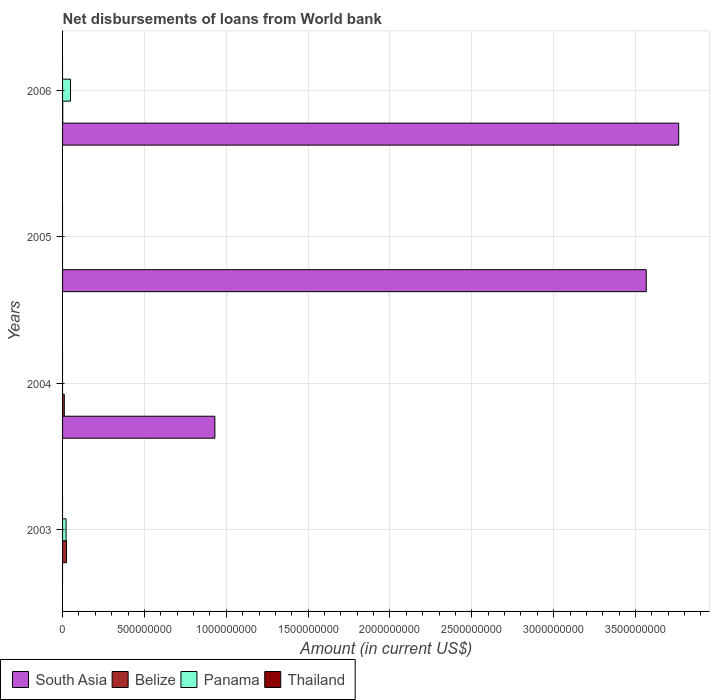How many different coloured bars are there?
Your answer should be very brief. 3. Are the number of bars per tick equal to the number of legend labels?
Offer a very short reply. No. How many bars are there on the 4th tick from the bottom?
Your response must be concise. 3. What is the label of the 4th group of bars from the top?
Ensure brevity in your answer.  2003. In how many cases, is the number of bars for a given year not equal to the number of legend labels?
Offer a terse response. 4. What is the amount of loan disbursed from World Bank in Thailand in 2006?
Make the answer very short. 0. Across all years, what is the maximum amount of loan disbursed from World Bank in Belize?
Make the answer very short. 2.42e+07. What is the total amount of loan disbursed from World Bank in Belize in the graph?
Offer a terse response. 3.57e+07. What is the difference between the amount of loan disbursed from World Bank in Belize in 2003 and that in 2004?
Provide a short and direct response. 1.36e+07. What is the average amount of loan disbursed from World Bank in Panama per year?
Offer a very short reply. 1.75e+07. In the year 2006, what is the difference between the amount of loan disbursed from World Bank in Belize and amount of loan disbursed from World Bank in South Asia?
Your response must be concise. -3.76e+09. In how many years, is the amount of loan disbursed from World Bank in Belize greater than 600000000 US$?
Your answer should be very brief. 0. What is the ratio of the amount of loan disbursed from World Bank in Belize in 2003 to that in 2006?
Keep it short and to the point. 26.44. Is the amount of loan disbursed from World Bank in South Asia in 2004 less than that in 2005?
Give a very brief answer. Yes. What is the difference between the highest and the second highest amount of loan disbursed from World Bank in South Asia?
Your answer should be very brief. 1.98e+08. What is the difference between the highest and the lowest amount of loan disbursed from World Bank in Panama?
Offer a terse response. 4.86e+07. In how many years, is the amount of loan disbursed from World Bank in South Asia greater than the average amount of loan disbursed from World Bank in South Asia taken over all years?
Offer a terse response. 2. Is the sum of the amount of loan disbursed from World Bank in South Asia in 2005 and 2006 greater than the maximum amount of loan disbursed from World Bank in Panama across all years?
Provide a succinct answer. Yes. Is it the case that in every year, the sum of the amount of loan disbursed from World Bank in South Asia and amount of loan disbursed from World Bank in Belize is greater than the amount of loan disbursed from World Bank in Panama?
Your response must be concise. Yes. How many bars are there?
Your response must be concise. 8. How many years are there in the graph?
Keep it short and to the point. 4. Does the graph contain grids?
Provide a succinct answer. Yes. How many legend labels are there?
Ensure brevity in your answer.  4. How are the legend labels stacked?
Your answer should be very brief. Horizontal. What is the title of the graph?
Give a very brief answer. Net disbursements of loans from World bank. What is the label or title of the Y-axis?
Give a very brief answer. Years. What is the Amount (in current US$) in South Asia in 2003?
Your answer should be compact. 0. What is the Amount (in current US$) in Belize in 2003?
Keep it short and to the point. 2.42e+07. What is the Amount (in current US$) of Panama in 2003?
Your response must be concise. 2.14e+07. What is the Amount (in current US$) in Thailand in 2003?
Your response must be concise. 0. What is the Amount (in current US$) of South Asia in 2004?
Offer a terse response. 9.30e+08. What is the Amount (in current US$) in Belize in 2004?
Ensure brevity in your answer.  1.06e+07. What is the Amount (in current US$) in Thailand in 2004?
Ensure brevity in your answer.  0. What is the Amount (in current US$) in South Asia in 2005?
Offer a very short reply. 3.57e+09. What is the Amount (in current US$) in Panama in 2005?
Provide a short and direct response. 0. What is the Amount (in current US$) in South Asia in 2006?
Ensure brevity in your answer.  3.76e+09. What is the Amount (in current US$) of Belize in 2006?
Your response must be concise. 9.15e+05. What is the Amount (in current US$) in Panama in 2006?
Ensure brevity in your answer.  4.86e+07. Across all years, what is the maximum Amount (in current US$) in South Asia?
Your answer should be very brief. 3.76e+09. Across all years, what is the maximum Amount (in current US$) in Belize?
Make the answer very short. 2.42e+07. Across all years, what is the maximum Amount (in current US$) of Panama?
Your response must be concise. 4.86e+07. Across all years, what is the minimum Amount (in current US$) of South Asia?
Offer a terse response. 0. Across all years, what is the minimum Amount (in current US$) in Belize?
Your answer should be compact. 0. Across all years, what is the minimum Amount (in current US$) of Panama?
Your response must be concise. 0. What is the total Amount (in current US$) of South Asia in the graph?
Your response must be concise. 8.26e+09. What is the total Amount (in current US$) in Belize in the graph?
Ensure brevity in your answer.  3.57e+07. What is the total Amount (in current US$) of Panama in the graph?
Make the answer very short. 7.00e+07. What is the total Amount (in current US$) of Thailand in the graph?
Your answer should be compact. 0. What is the difference between the Amount (in current US$) in Belize in 2003 and that in 2004?
Your answer should be very brief. 1.36e+07. What is the difference between the Amount (in current US$) of Belize in 2003 and that in 2006?
Make the answer very short. 2.33e+07. What is the difference between the Amount (in current US$) of Panama in 2003 and that in 2006?
Your response must be concise. -2.72e+07. What is the difference between the Amount (in current US$) of South Asia in 2004 and that in 2005?
Provide a succinct answer. -2.64e+09. What is the difference between the Amount (in current US$) of South Asia in 2004 and that in 2006?
Provide a succinct answer. -2.83e+09. What is the difference between the Amount (in current US$) in Belize in 2004 and that in 2006?
Provide a short and direct response. 9.71e+06. What is the difference between the Amount (in current US$) in South Asia in 2005 and that in 2006?
Offer a terse response. -1.98e+08. What is the difference between the Amount (in current US$) of Belize in 2003 and the Amount (in current US$) of Panama in 2006?
Your answer should be very brief. -2.44e+07. What is the difference between the Amount (in current US$) of South Asia in 2004 and the Amount (in current US$) of Belize in 2006?
Keep it short and to the point. 9.29e+08. What is the difference between the Amount (in current US$) in South Asia in 2004 and the Amount (in current US$) in Panama in 2006?
Your answer should be very brief. 8.82e+08. What is the difference between the Amount (in current US$) in Belize in 2004 and the Amount (in current US$) in Panama in 2006?
Ensure brevity in your answer.  -3.80e+07. What is the difference between the Amount (in current US$) in South Asia in 2005 and the Amount (in current US$) in Belize in 2006?
Your response must be concise. 3.56e+09. What is the difference between the Amount (in current US$) of South Asia in 2005 and the Amount (in current US$) of Panama in 2006?
Keep it short and to the point. 3.52e+09. What is the average Amount (in current US$) in South Asia per year?
Your answer should be very brief. 2.06e+09. What is the average Amount (in current US$) of Belize per year?
Your answer should be very brief. 8.93e+06. What is the average Amount (in current US$) of Panama per year?
Your response must be concise. 1.75e+07. What is the average Amount (in current US$) of Thailand per year?
Offer a terse response. 0. In the year 2003, what is the difference between the Amount (in current US$) of Belize and Amount (in current US$) of Panama?
Your answer should be compact. 2.79e+06. In the year 2004, what is the difference between the Amount (in current US$) of South Asia and Amount (in current US$) of Belize?
Provide a succinct answer. 9.20e+08. In the year 2006, what is the difference between the Amount (in current US$) in South Asia and Amount (in current US$) in Belize?
Give a very brief answer. 3.76e+09. In the year 2006, what is the difference between the Amount (in current US$) of South Asia and Amount (in current US$) of Panama?
Ensure brevity in your answer.  3.72e+09. In the year 2006, what is the difference between the Amount (in current US$) of Belize and Amount (in current US$) of Panama?
Your answer should be very brief. -4.77e+07. What is the ratio of the Amount (in current US$) in Belize in 2003 to that in 2004?
Provide a short and direct response. 2.28. What is the ratio of the Amount (in current US$) of Belize in 2003 to that in 2006?
Give a very brief answer. 26.44. What is the ratio of the Amount (in current US$) of Panama in 2003 to that in 2006?
Offer a terse response. 0.44. What is the ratio of the Amount (in current US$) of South Asia in 2004 to that in 2005?
Your answer should be compact. 0.26. What is the ratio of the Amount (in current US$) in South Asia in 2004 to that in 2006?
Your response must be concise. 0.25. What is the ratio of the Amount (in current US$) of Belize in 2004 to that in 2006?
Offer a terse response. 11.61. What is the ratio of the Amount (in current US$) of South Asia in 2005 to that in 2006?
Make the answer very short. 0.95. What is the difference between the highest and the second highest Amount (in current US$) of South Asia?
Provide a short and direct response. 1.98e+08. What is the difference between the highest and the second highest Amount (in current US$) in Belize?
Make the answer very short. 1.36e+07. What is the difference between the highest and the lowest Amount (in current US$) of South Asia?
Give a very brief answer. 3.76e+09. What is the difference between the highest and the lowest Amount (in current US$) of Belize?
Provide a short and direct response. 2.42e+07. What is the difference between the highest and the lowest Amount (in current US$) in Panama?
Your response must be concise. 4.86e+07. 